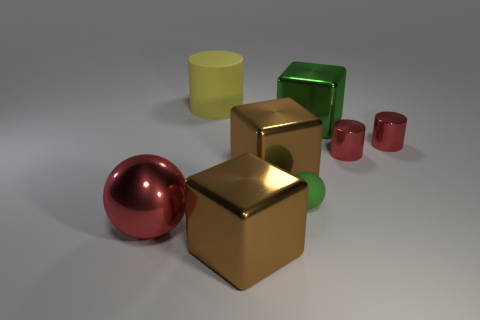Add 2 small purple balls. How many objects exist? 10 Subtract all red cylinders. How many cylinders are left? 1 Subtract all purple blocks. How many red cylinders are left? 2 Subtract all blocks. How many objects are left? 5 Add 1 metallic balls. How many metallic balls are left? 2 Add 7 yellow rubber cylinders. How many yellow rubber cylinders exist? 8 Subtract all green blocks. How many blocks are left? 2 Subtract 0 cyan cubes. How many objects are left? 8 Subtract 2 cylinders. How many cylinders are left? 1 Subtract all yellow cubes. Subtract all blue cylinders. How many cubes are left? 3 